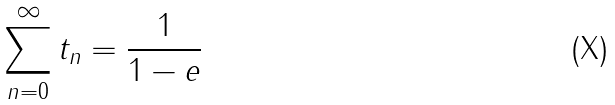Convert formula to latex. <formula><loc_0><loc_0><loc_500><loc_500>\sum _ { n = 0 } ^ { \infty } t _ { n } = \frac { 1 } { 1 - e }</formula> 